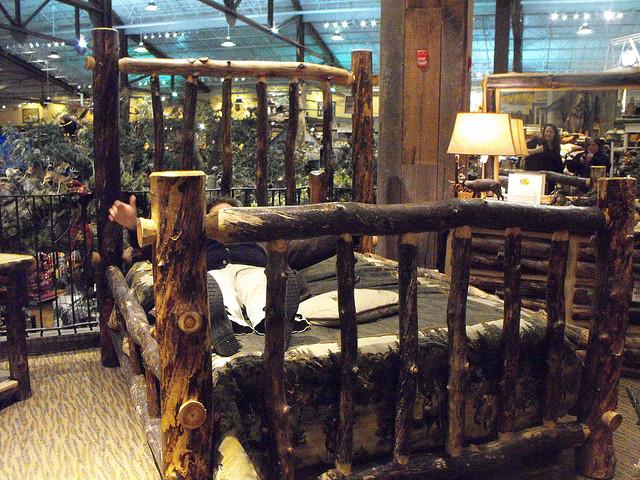Is this bed located in a store?
Concise answer only. Yes. Do the women in the back think he is funny?
Concise answer only. No. What is the bed made out of?
Be succinct. Wood. 